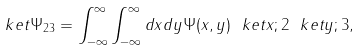Convert formula to latex. <formula><loc_0><loc_0><loc_500><loc_500>\ k e t { \Psi _ { 2 3 } } = \int _ { - \infty } ^ { \infty } \int _ { - \infty } ^ { \infty } d x d y \Psi ( x , y ) \ k e t { x ; 2 } \ k e t { y ; 3 } ,</formula> 